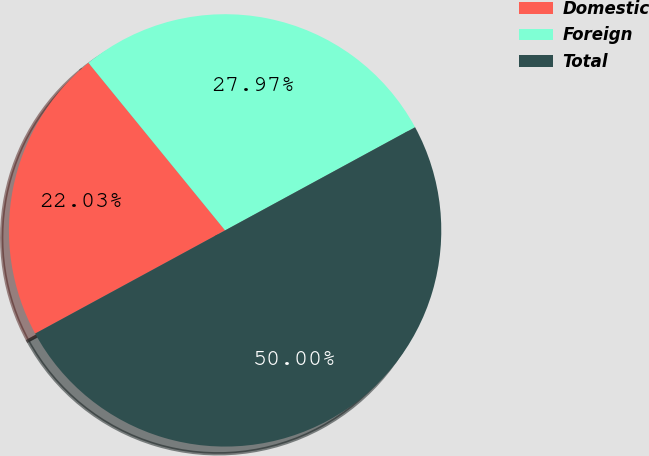Convert chart to OTSL. <chart><loc_0><loc_0><loc_500><loc_500><pie_chart><fcel>Domestic<fcel>Foreign<fcel>Total<nl><fcel>22.03%<fcel>27.97%<fcel>50.0%<nl></chart> 